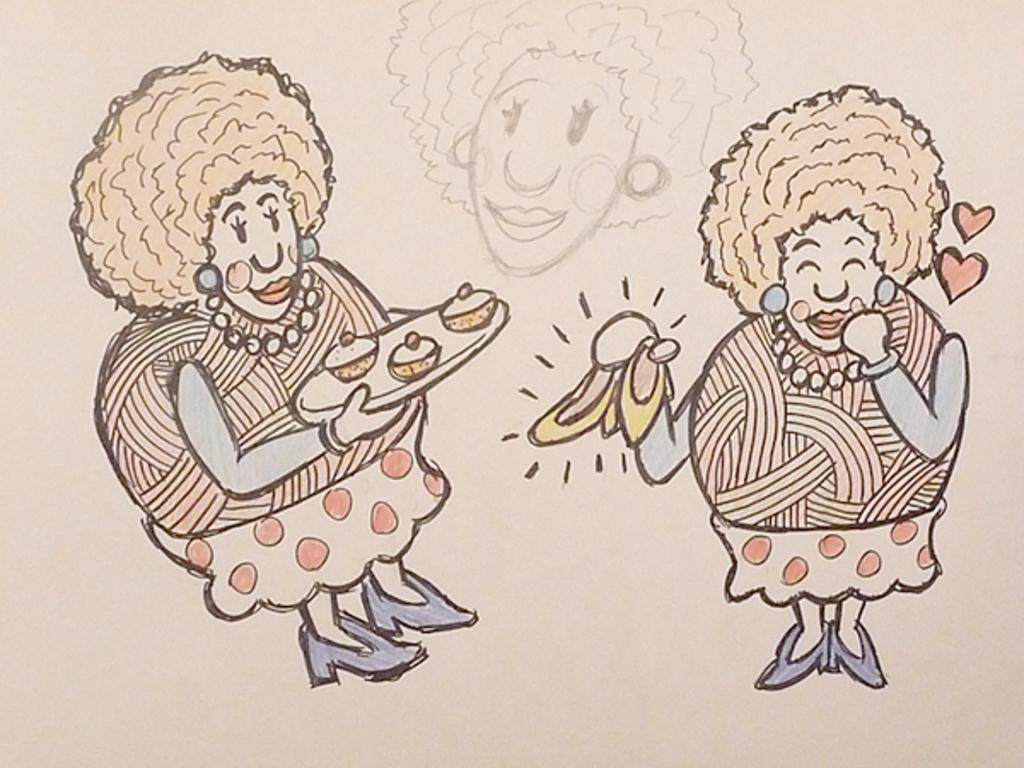What type of drawings are present in the image? The image contains cartoon sketches. Can you describe the style or genre of the drawings? The style of the drawings is cartoonish, which means they are simplified and often humorous or exaggerated representations of characters or objects. What type of drink is being served in the cartoon sketch? There is no drink being served in the cartoon sketch, as the image only contains drawings and no actual objects or scenes. 